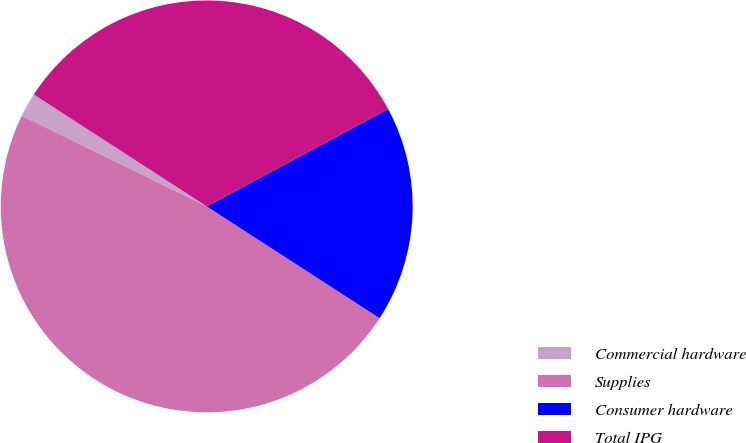Convert chart. <chart><loc_0><loc_0><loc_500><loc_500><pie_chart><fcel>Commercial hardware<fcel>Supplies<fcel>Consumer hardware<fcel>Total IPG<nl><fcel>1.89%<fcel>48.11%<fcel>16.98%<fcel>33.02%<nl></chart> 